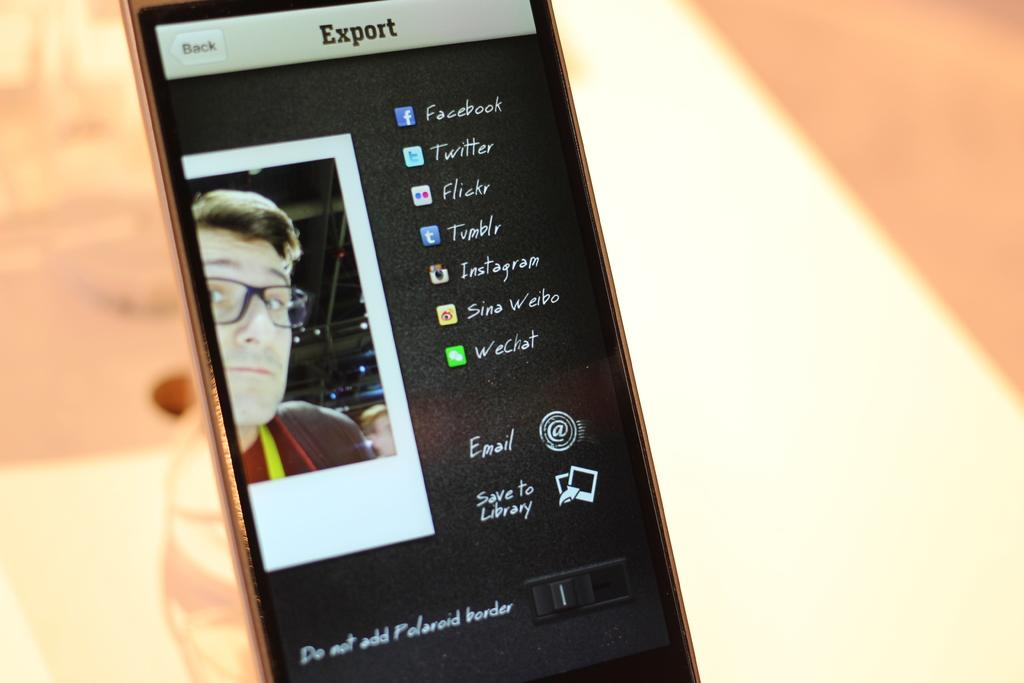<image>
Relay a brief, clear account of the picture shown. a cell phone displays an export screen to social media accounts 